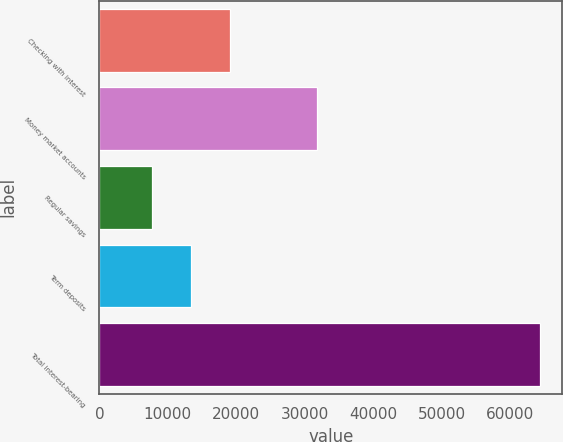<chart> <loc_0><loc_0><loc_500><loc_500><bar_chart><fcel>Checking with interest<fcel>Money market accounts<fcel>Regular savings<fcel>Term deposits<fcel>Total interest-bearing<nl><fcel>19064.6<fcel>31849<fcel>7730<fcel>13397.3<fcel>64403<nl></chart> 